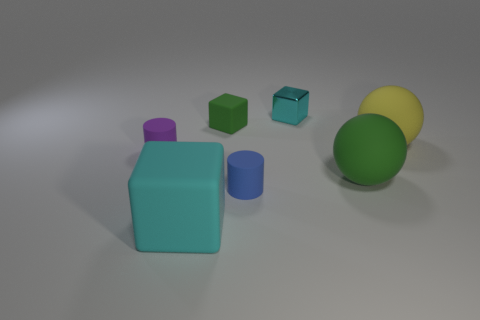What is the shape of the thing that is the same color as the small matte block?
Offer a terse response. Sphere. There is a tiny green thing; is its shape the same as the tiny object that is right of the tiny blue matte cylinder?
Offer a terse response. Yes. What is the shape of the big rubber object that is both in front of the large yellow matte thing and behind the big cyan object?
Your response must be concise. Sphere. Are there an equal number of metal things that are on the left side of the big cyan cube and green rubber objects that are to the right of the yellow rubber object?
Make the answer very short. Yes. There is a rubber thing to the left of the big cyan rubber thing; does it have the same shape as the big yellow rubber thing?
Make the answer very short. No. What number of blue objects are tiny rubber blocks or matte blocks?
Provide a succinct answer. 0. There is another small cyan object that is the same shape as the cyan matte object; what is its material?
Your answer should be very brief. Metal. There is a small matte object behind the small purple cylinder; what shape is it?
Ensure brevity in your answer.  Cube. Are there any tiny cyan blocks that have the same material as the large cyan cube?
Offer a terse response. No. Does the blue cylinder have the same size as the metallic block?
Ensure brevity in your answer.  Yes. 